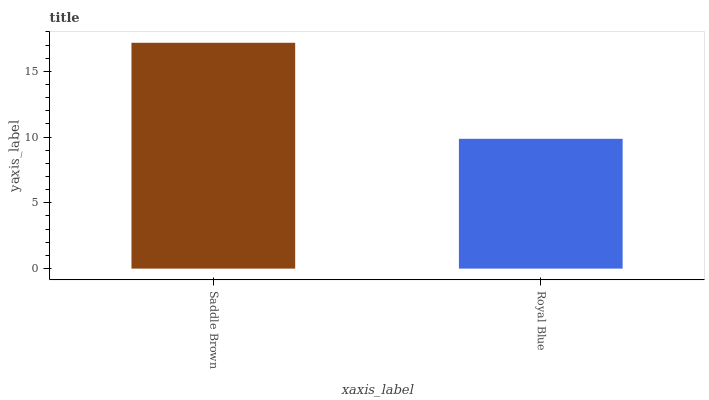Is Royal Blue the maximum?
Answer yes or no. No. Is Saddle Brown greater than Royal Blue?
Answer yes or no. Yes. Is Royal Blue less than Saddle Brown?
Answer yes or no. Yes. Is Royal Blue greater than Saddle Brown?
Answer yes or no. No. Is Saddle Brown less than Royal Blue?
Answer yes or no. No. Is Saddle Brown the high median?
Answer yes or no. Yes. Is Royal Blue the low median?
Answer yes or no. Yes. Is Royal Blue the high median?
Answer yes or no. No. Is Saddle Brown the low median?
Answer yes or no. No. 